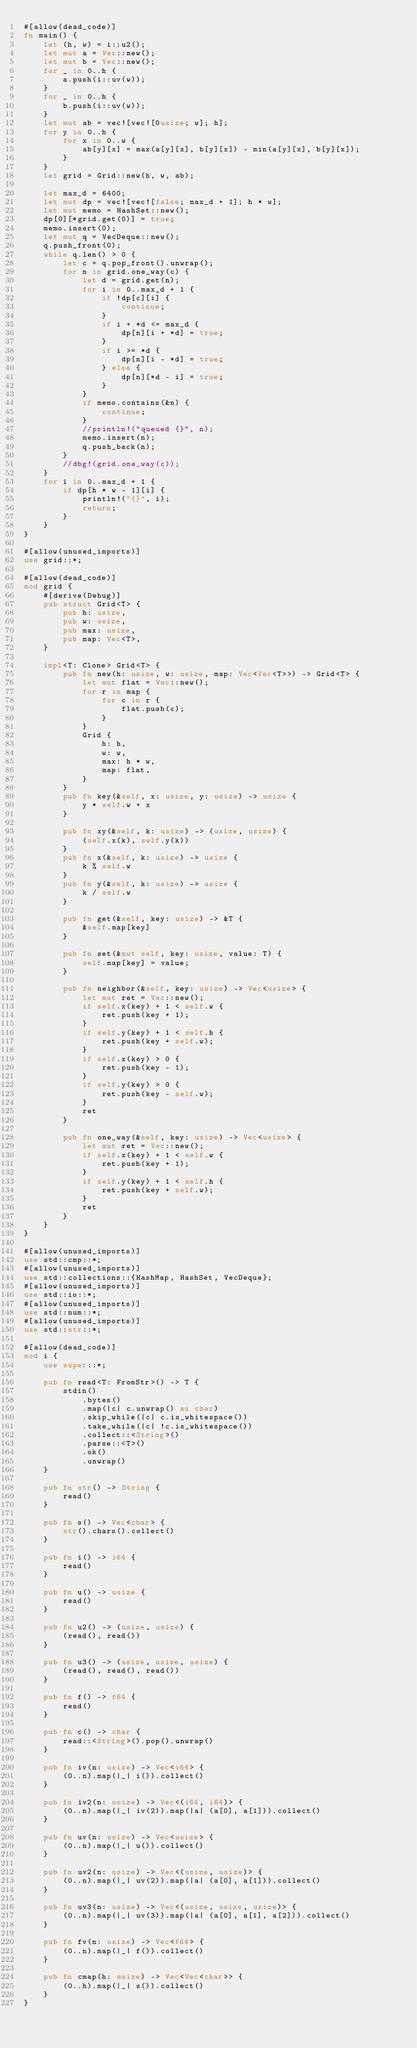Convert code to text. <code><loc_0><loc_0><loc_500><loc_500><_Rust_>#[allow(dead_code)]
fn main() {
    let (h, w) = i::u2();
    let mut a = Vec::new();
    let mut b = Vec::new();
    for _ in 0..h {
        a.push(i::uv(w));
    }
    for _ in 0..h {
        b.push(i::uv(w));
    }
    let mut ab = vec![vec![0usize; w]; h];
    for y in 0..h {
        for x in 0..w {
            ab[y][x] = max(a[y][x], b[y][x]) - min(a[y][x], b[y][x]);
        }
    }
    let grid = Grid::new(h, w, ab);

    let max_d = 6400;
    let mut dp = vec![vec![false; max_d + 1]; h * w];
    let mut memo = HashSet::new();
    dp[0][*grid.get(0)] = true;
    memo.insert(0);
    let mut q = VecDeque::new();
    q.push_front(0);
    while q.len() > 0 {
        let c = q.pop_front().unwrap();
        for n in grid.one_way(c) {
            let d = grid.get(n);
            for i in 0..max_d + 1 {
                if !dp[c][i] {
                    continue;
                }
                if i + *d <= max_d {
                    dp[n][i + *d] = true;
                }
                if i >= *d {
                    dp[n][i - *d] = true;
                } else {
                    dp[n][*d - i] = true;
                }
            }
            if memo.contains(&n) {
                continue;
            }
            //println!("queued {}", n);
            memo.insert(n);
            q.push_back(n);
        }
        //dbg!(grid.one_way(c));
    }
    for i in 0..max_d + 1 {
        if dp[h * w - 1][i] {
            println!("{}", i);
            return;
        }
    }
}

#[allow(unused_imports)]
use grid::*;

#[allow(dead_code)]
mod grid {
    #[derive(Debug)]
    pub struct Grid<T> {
        pub h: usize,
        pub w: usize,
        pub max: usize,
        pub map: Vec<T>,
    }

    impl<T: Clone> Grid<T> {
        pub fn new(h: usize, w: usize, map: Vec<Vec<T>>) -> Grid<T> {
            let mut flat = Vec::new();
            for r in map {
                for c in r {
                    flat.push(c);
                }
            }
            Grid {
                h: h,
                w: w,
                max: h * w,
                map: flat,
            }
        }
        pub fn key(&self, x: usize, y: usize) -> usize {
            y * self.w + x
        }

        pub fn xy(&self, k: usize) -> (usize, usize) {
            (self.x(k), self.y(k))
        }
        pub fn x(&self, k: usize) -> usize {
            k % self.w
        }
        pub fn y(&self, k: usize) -> usize {
            k / self.w
        }

        pub fn get(&self, key: usize) -> &T {
            &self.map[key]
        }

        pub fn set(&mut self, key: usize, value: T) {
            self.map[key] = value;
        }

        pub fn neighbor(&self, key: usize) -> Vec<usize> {
            let mut ret = Vec::new();
            if self.x(key) + 1 < self.w {
                ret.push(key + 1);
            }
            if self.y(key) + 1 < self.h {
                ret.push(key + self.w);
            }
            if self.x(key) > 0 {
                ret.push(key - 1);
            }
            if self.y(key) > 0 {
                ret.push(key - self.w);
            }
            ret
        }

        pub fn one_way(&self, key: usize) -> Vec<usize> {
            let mut ret = Vec::new();
            if self.x(key) + 1 < self.w {
                ret.push(key + 1);
            }
            if self.y(key) + 1 < self.h {
                ret.push(key + self.w);
            }
            ret
        }
    }
}

#[allow(unused_imports)]
use std::cmp::*;
#[allow(unused_imports)]
use std::collections::{HashMap, HashSet, VecDeque};
#[allow(unused_imports)]
use std::io::*;
#[allow(unused_imports)]
use std::num::*;
#[allow(unused_imports)]
use std::str::*;

#[allow(dead_code)]
mod i {
    use super::*;

    pub fn read<T: FromStr>() -> T {
        stdin()
            .bytes()
            .map(|c| c.unwrap() as char)
            .skip_while(|c| c.is_whitespace())
            .take_while(|c| !c.is_whitespace())
            .collect::<String>()
            .parse::<T>()
            .ok()
            .unwrap()
    }

    pub fn str() -> String {
        read()
    }

    pub fn s() -> Vec<char> {
        str().chars().collect()
    }

    pub fn i() -> i64 {
        read()
    }

    pub fn u() -> usize {
        read()
    }

    pub fn u2() -> (usize, usize) {
        (read(), read())
    }

    pub fn u3() -> (usize, usize, usize) {
        (read(), read(), read())
    }

    pub fn f() -> f64 {
        read()
    }

    pub fn c() -> char {
        read::<String>().pop().unwrap()
    }

    pub fn iv(n: usize) -> Vec<i64> {
        (0..n).map(|_| i()).collect()
    }

    pub fn iv2(n: usize) -> Vec<(i64, i64)> {
        (0..n).map(|_| iv(2)).map(|a| (a[0], a[1])).collect()
    }

    pub fn uv(n: usize) -> Vec<usize> {
        (0..n).map(|_| u()).collect()
    }

    pub fn uv2(n: usize) -> Vec<(usize, usize)> {
        (0..n).map(|_| uv(2)).map(|a| (a[0], a[1])).collect()
    }

    pub fn uv3(n: usize) -> Vec<(usize, usize, usize)> {
        (0..n).map(|_| uv(3)).map(|a| (a[0], a[1], a[2])).collect()
    }

    pub fn fv(n: usize) -> Vec<f64> {
        (0..n).map(|_| f()).collect()
    }

    pub fn cmap(h: usize) -> Vec<Vec<char>> {
        (0..h).map(|_| s()).collect()
    }
}
</code> 